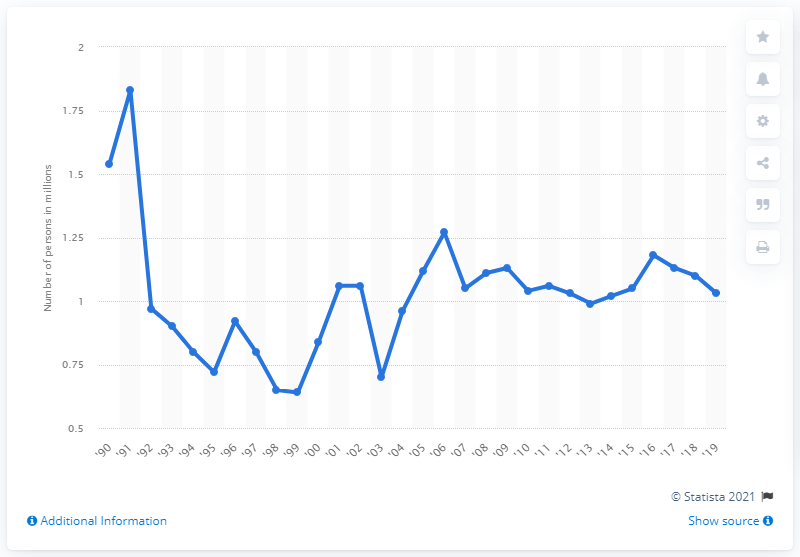Specify some key components in this picture. In 2019, a total of 1,030,000 immigrants were granted legal permanent resident status in the United States. 